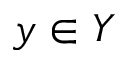<formula> <loc_0><loc_0><loc_500><loc_500>y \in Y</formula> 